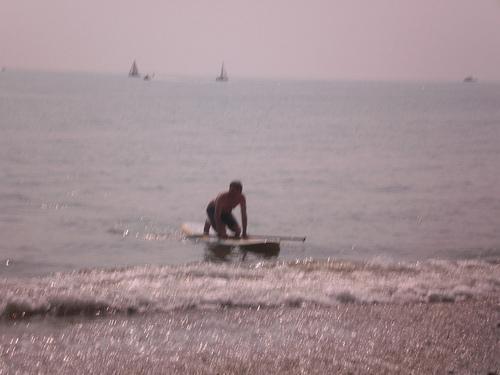How many people are in the photo?
Give a very brief answer. 1. How many boats are in the photo?
Give a very brief answer. 4. 